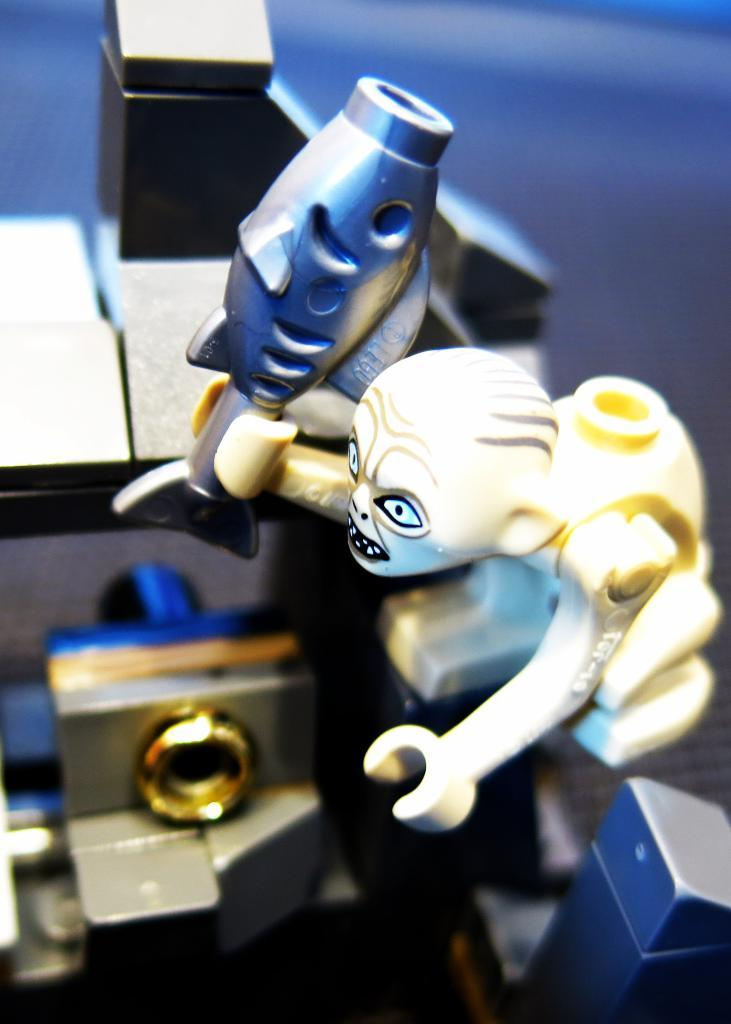What objects are placed on the surface in the image? There are toys placed on a surface in the image. How many knots are tied on the toys in the image? There is no information about knots on the toys in the image, as it only mentions that there are toys placed on a surface. 